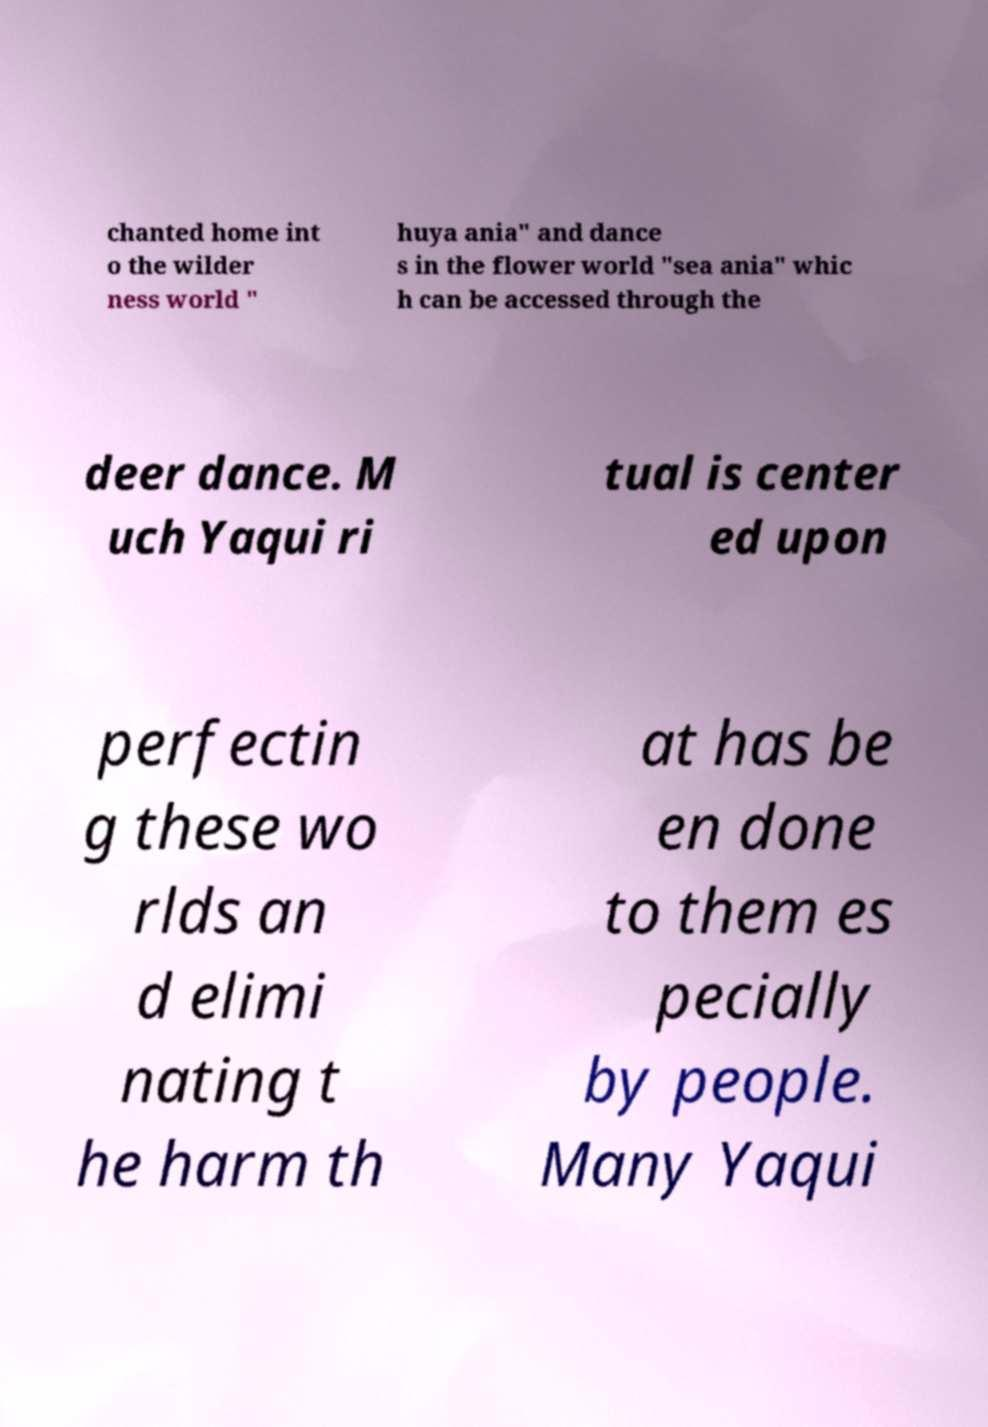Could you extract and type out the text from this image? chanted home int o the wilder ness world " huya ania" and dance s in the flower world "sea ania" whic h can be accessed through the deer dance. M uch Yaqui ri tual is center ed upon perfectin g these wo rlds an d elimi nating t he harm th at has be en done to them es pecially by people. Many Yaqui 